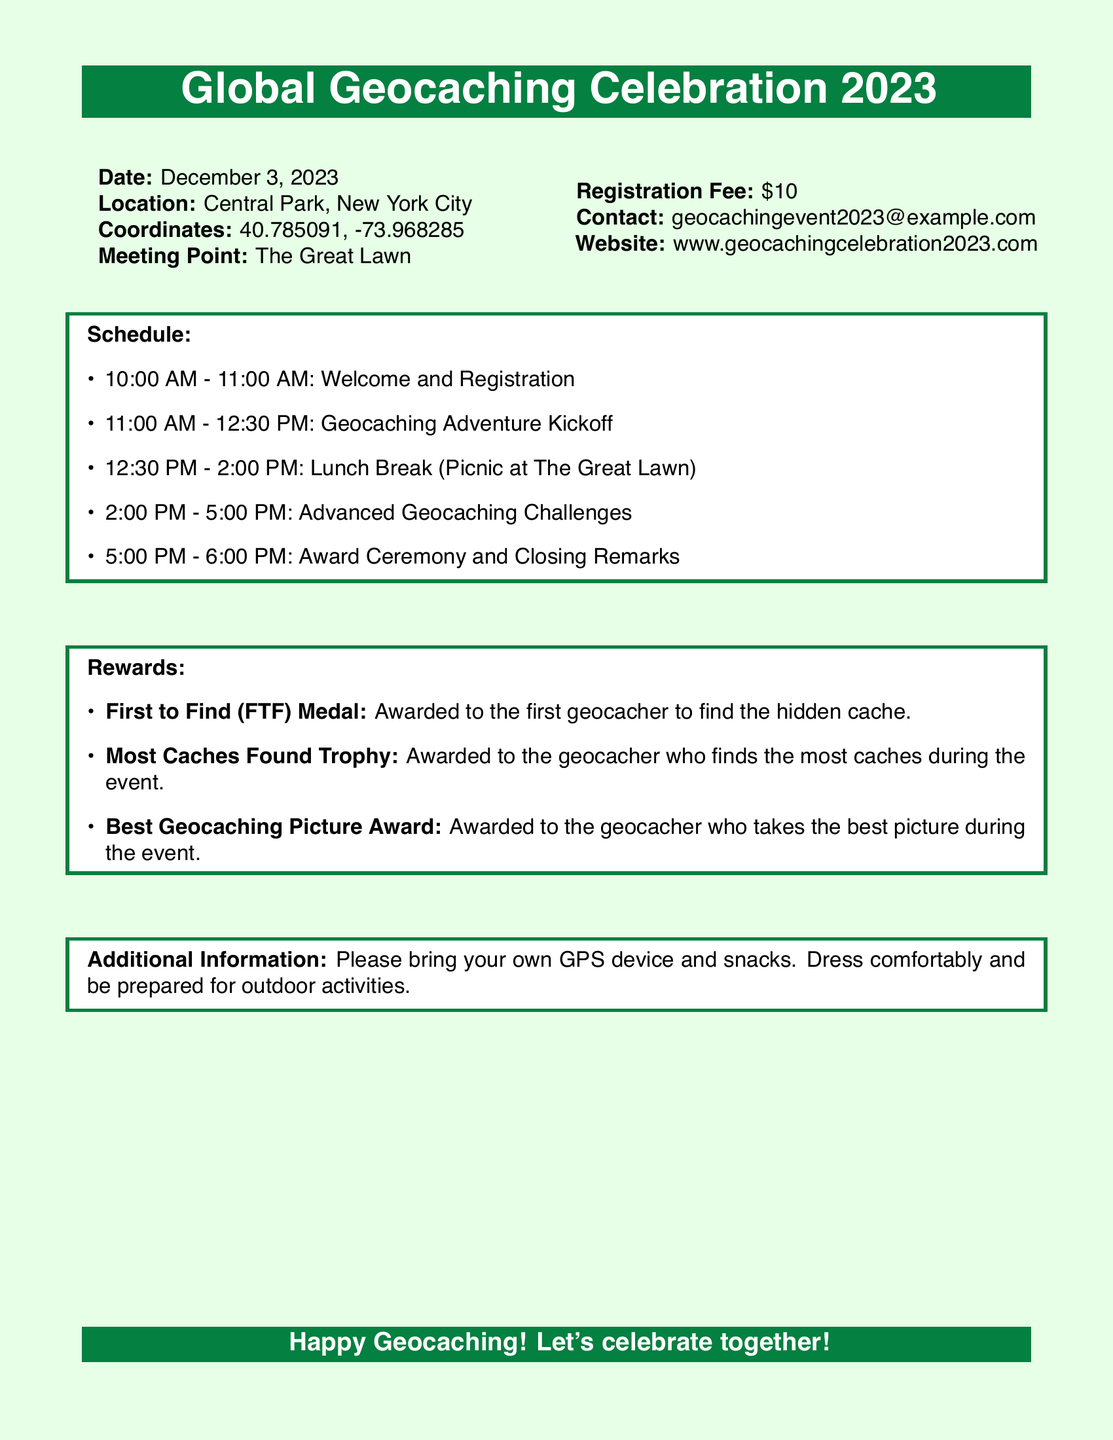What is the date of the event? The date of the event is mentioned in the document.
Answer: December 3, 2023 Where is the event taking place? The location of the event is provided in the document.
Answer: Central Park, New York City What is the registration fee? The document specifies the amount for registration.
Answer: $10 What are the coordinates for the event location? The coordinates are listed in the details provided in the document.
Answer: 40.785091, -73.968285 What time does the Award Ceremony start? The schedule outlines the timing for each segment of the event.
Answer: 5:00 PM Who can win the "Most Caches Found Trophy"? This award is designated for the geocacher who finds the most caches during the event.
Answer: The geocacher who finds the most caches What should attendees bring for the event? The additional information section specifies recommendations for attendees.
Answer: GPS device and snacks What is the meeting point for the event? The document clearly mentions the meeting point.
Answer: The Great Lawn What is the contact email for the event? The document provides contact information for inquiries.
Answer: geocachingevent2023@example.com 